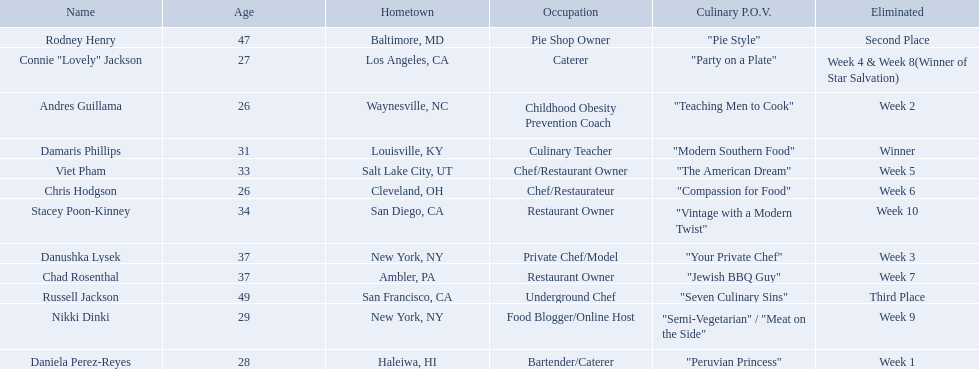Who are all of the contestants? Damaris Phillips, Rodney Henry, Russell Jackson, Stacey Poon-Kinney, Nikki Dinki, Chad Rosenthal, Chris Hodgson, Viet Pham, Connie "Lovely" Jackson, Danushka Lysek, Andres Guillama, Daniela Perez-Reyes. What is each player's culinary point of view? "Modern Southern Food", "Pie Style", "Seven Culinary Sins", "Vintage with a Modern Twist", "Semi-Vegetarian" / "Meat on the Side", "Jewish BBQ Guy", "Compassion for Food", "The American Dream", "Party on a Plate", "Your Private Chef", "Teaching Men to Cook", "Peruvian Princess". And which player's point of view is the longest? Nikki Dinki. 